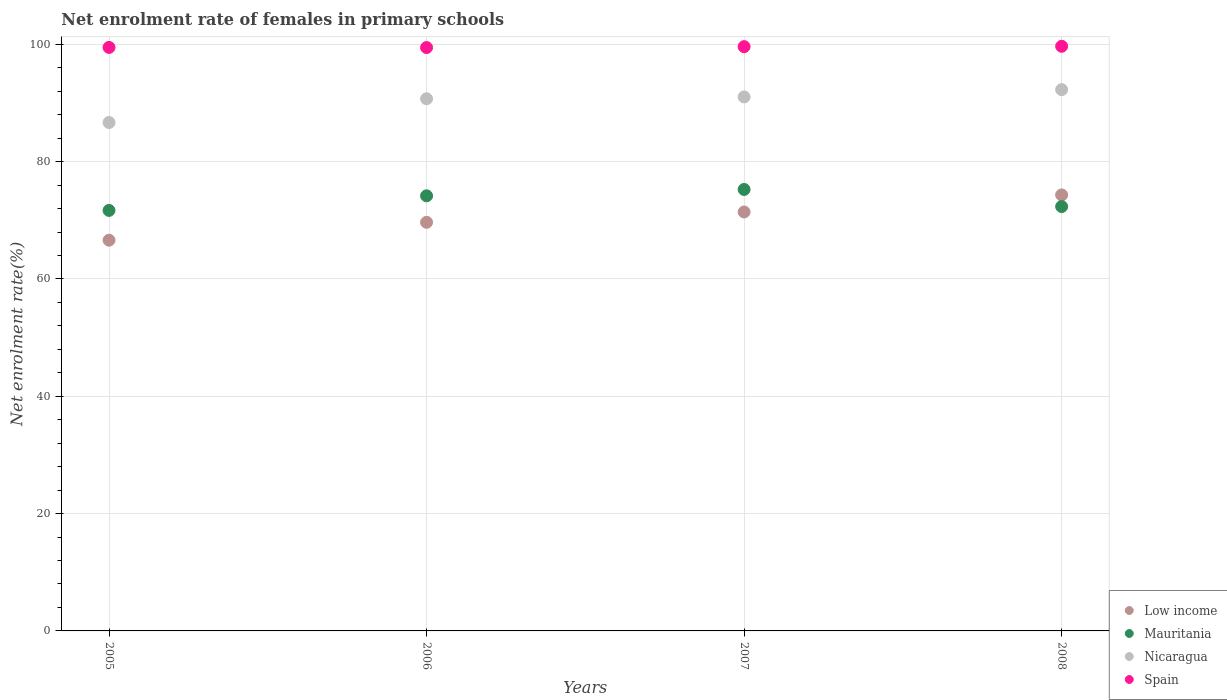Is the number of dotlines equal to the number of legend labels?
Make the answer very short. Yes. What is the net enrolment rate of females in primary schools in Low income in 2006?
Provide a succinct answer. 69.66. Across all years, what is the maximum net enrolment rate of females in primary schools in Low income?
Offer a terse response. 74.33. Across all years, what is the minimum net enrolment rate of females in primary schools in Mauritania?
Your answer should be compact. 71.69. What is the total net enrolment rate of females in primary schools in Spain in the graph?
Offer a terse response. 398.21. What is the difference between the net enrolment rate of females in primary schools in Low income in 2005 and that in 2007?
Your answer should be very brief. -4.82. What is the difference between the net enrolment rate of females in primary schools in Mauritania in 2007 and the net enrolment rate of females in primary schools in Spain in 2008?
Offer a terse response. -24.41. What is the average net enrolment rate of females in primary schools in Spain per year?
Give a very brief answer. 99.55. In the year 2007, what is the difference between the net enrolment rate of females in primary schools in Spain and net enrolment rate of females in primary schools in Nicaragua?
Provide a succinct answer. 8.57. In how many years, is the net enrolment rate of females in primary schools in Nicaragua greater than 24 %?
Ensure brevity in your answer.  4. What is the ratio of the net enrolment rate of females in primary schools in Mauritania in 2005 to that in 2007?
Your response must be concise. 0.95. Is the net enrolment rate of females in primary schools in Spain in 2005 less than that in 2006?
Provide a short and direct response. No. What is the difference between the highest and the second highest net enrolment rate of females in primary schools in Spain?
Ensure brevity in your answer.  0.06. What is the difference between the highest and the lowest net enrolment rate of females in primary schools in Mauritania?
Your answer should be compact. 3.57. In how many years, is the net enrolment rate of females in primary schools in Low income greater than the average net enrolment rate of females in primary schools in Low income taken over all years?
Give a very brief answer. 2. Is it the case that in every year, the sum of the net enrolment rate of females in primary schools in Low income and net enrolment rate of females in primary schools in Spain  is greater than the net enrolment rate of females in primary schools in Nicaragua?
Keep it short and to the point. Yes. Is the net enrolment rate of females in primary schools in Low income strictly greater than the net enrolment rate of females in primary schools in Spain over the years?
Give a very brief answer. No. How many years are there in the graph?
Ensure brevity in your answer.  4. Does the graph contain any zero values?
Give a very brief answer. No. Does the graph contain grids?
Offer a terse response. Yes. What is the title of the graph?
Keep it short and to the point. Net enrolment rate of females in primary schools. Does "Italy" appear as one of the legend labels in the graph?
Your answer should be very brief. No. What is the label or title of the X-axis?
Provide a succinct answer. Years. What is the label or title of the Y-axis?
Your answer should be compact. Net enrolment rate(%). What is the Net enrolment rate(%) in Low income in 2005?
Offer a very short reply. 66.61. What is the Net enrolment rate(%) in Mauritania in 2005?
Offer a very short reply. 71.69. What is the Net enrolment rate(%) in Nicaragua in 2005?
Your answer should be very brief. 86.67. What is the Net enrolment rate(%) of Spain in 2005?
Provide a succinct answer. 99.48. What is the Net enrolment rate(%) in Low income in 2006?
Give a very brief answer. 69.66. What is the Net enrolment rate(%) in Mauritania in 2006?
Make the answer very short. 74.18. What is the Net enrolment rate(%) of Nicaragua in 2006?
Offer a terse response. 90.72. What is the Net enrolment rate(%) of Spain in 2006?
Provide a succinct answer. 99.45. What is the Net enrolment rate(%) of Low income in 2007?
Your answer should be very brief. 71.43. What is the Net enrolment rate(%) of Mauritania in 2007?
Make the answer very short. 75.26. What is the Net enrolment rate(%) of Nicaragua in 2007?
Make the answer very short. 91.03. What is the Net enrolment rate(%) in Spain in 2007?
Make the answer very short. 99.61. What is the Net enrolment rate(%) in Low income in 2008?
Your answer should be very brief. 74.33. What is the Net enrolment rate(%) in Mauritania in 2008?
Offer a terse response. 72.34. What is the Net enrolment rate(%) of Nicaragua in 2008?
Your answer should be very brief. 92.28. What is the Net enrolment rate(%) of Spain in 2008?
Keep it short and to the point. 99.67. Across all years, what is the maximum Net enrolment rate(%) of Low income?
Provide a short and direct response. 74.33. Across all years, what is the maximum Net enrolment rate(%) in Mauritania?
Your answer should be compact. 75.26. Across all years, what is the maximum Net enrolment rate(%) of Nicaragua?
Your answer should be compact. 92.28. Across all years, what is the maximum Net enrolment rate(%) of Spain?
Provide a short and direct response. 99.67. Across all years, what is the minimum Net enrolment rate(%) of Low income?
Make the answer very short. 66.61. Across all years, what is the minimum Net enrolment rate(%) in Mauritania?
Your answer should be very brief. 71.69. Across all years, what is the minimum Net enrolment rate(%) of Nicaragua?
Your response must be concise. 86.67. Across all years, what is the minimum Net enrolment rate(%) of Spain?
Your answer should be very brief. 99.45. What is the total Net enrolment rate(%) of Low income in the graph?
Keep it short and to the point. 282.02. What is the total Net enrolment rate(%) in Mauritania in the graph?
Ensure brevity in your answer.  293.47. What is the total Net enrolment rate(%) in Nicaragua in the graph?
Offer a very short reply. 360.71. What is the total Net enrolment rate(%) of Spain in the graph?
Offer a very short reply. 398.21. What is the difference between the Net enrolment rate(%) of Low income in 2005 and that in 2006?
Keep it short and to the point. -3.05. What is the difference between the Net enrolment rate(%) of Mauritania in 2005 and that in 2006?
Provide a succinct answer. -2.49. What is the difference between the Net enrolment rate(%) of Nicaragua in 2005 and that in 2006?
Make the answer very short. -4.05. What is the difference between the Net enrolment rate(%) of Spain in 2005 and that in 2006?
Keep it short and to the point. 0.02. What is the difference between the Net enrolment rate(%) of Low income in 2005 and that in 2007?
Your response must be concise. -4.82. What is the difference between the Net enrolment rate(%) of Mauritania in 2005 and that in 2007?
Make the answer very short. -3.57. What is the difference between the Net enrolment rate(%) of Nicaragua in 2005 and that in 2007?
Your answer should be compact. -4.36. What is the difference between the Net enrolment rate(%) of Spain in 2005 and that in 2007?
Ensure brevity in your answer.  -0.13. What is the difference between the Net enrolment rate(%) in Low income in 2005 and that in 2008?
Ensure brevity in your answer.  -7.72. What is the difference between the Net enrolment rate(%) of Mauritania in 2005 and that in 2008?
Keep it short and to the point. -0.66. What is the difference between the Net enrolment rate(%) in Nicaragua in 2005 and that in 2008?
Keep it short and to the point. -5.6. What is the difference between the Net enrolment rate(%) of Spain in 2005 and that in 2008?
Offer a terse response. -0.2. What is the difference between the Net enrolment rate(%) in Low income in 2006 and that in 2007?
Provide a short and direct response. -1.77. What is the difference between the Net enrolment rate(%) of Mauritania in 2006 and that in 2007?
Offer a terse response. -1.08. What is the difference between the Net enrolment rate(%) in Nicaragua in 2006 and that in 2007?
Your answer should be compact. -0.31. What is the difference between the Net enrolment rate(%) in Spain in 2006 and that in 2007?
Keep it short and to the point. -0.15. What is the difference between the Net enrolment rate(%) in Low income in 2006 and that in 2008?
Offer a very short reply. -4.67. What is the difference between the Net enrolment rate(%) of Mauritania in 2006 and that in 2008?
Provide a succinct answer. 1.83. What is the difference between the Net enrolment rate(%) of Nicaragua in 2006 and that in 2008?
Keep it short and to the point. -1.55. What is the difference between the Net enrolment rate(%) of Spain in 2006 and that in 2008?
Make the answer very short. -0.22. What is the difference between the Net enrolment rate(%) of Low income in 2007 and that in 2008?
Offer a very short reply. -2.9. What is the difference between the Net enrolment rate(%) of Mauritania in 2007 and that in 2008?
Provide a short and direct response. 2.92. What is the difference between the Net enrolment rate(%) in Nicaragua in 2007 and that in 2008?
Provide a short and direct response. -1.24. What is the difference between the Net enrolment rate(%) of Spain in 2007 and that in 2008?
Ensure brevity in your answer.  -0.06. What is the difference between the Net enrolment rate(%) of Low income in 2005 and the Net enrolment rate(%) of Mauritania in 2006?
Provide a succinct answer. -7.57. What is the difference between the Net enrolment rate(%) of Low income in 2005 and the Net enrolment rate(%) of Nicaragua in 2006?
Ensure brevity in your answer.  -24.11. What is the difference between the Net enrolment rate(%) in Low income in 2005 and the Net enrolment rate(%) in Spain in 2006?
Give a very brief answer. -32.84. What is the difference between the Net enrolment rate(%) in Mauritania in 2005 and the Net enrolment rate(%) in Nicaragua in 2006?
Your answer should be compact. -19.03. What is the difference between the Net enrolment rate(%) of Mauritania in 2005 and the Net enrolment rate(%) of Spain in 2006?
Offer a very short reply. -27.76. What is the difference between the Net enrolment rate(%) in Nicaragua in 2005 and the Net enrolment rate(%) in Spain in 2006?
Offer a terse response. -12.78. What is the difference between the Net enrolment rate(%) of Low income in 2005 and the Net enrolment rate(%) of Mauritania in 2007?
Provide a succinct answer. -8.65. What is the difference between the Net enrolment rate(%) of Low income in 2005 and the Net enrolment rate(%) of Nicaragua in 2007?
Keep it short and to the point. -24.42. What is the difference between the Net enrolment rate(%) in Low income in 2005 and the Net enrolment rate(%) in Spain in 2007?
Keep it short and to the point. -33. What is the difference between the Net enrolment rate(%) of Mauritania in 2005 and the Net enrolment rate(%) of Nicaragua in 2007?
Offer a very short reply. -19.34. What is the difference between the Net enrolment rate(%) in Mauritania in 2005 and the Net enrolment rate(%) in Spain in 2007?
Make the answer very short. -27.92. What is the difference between the Net enrolment rate(%) in Nicaragua in 2005 and the Net enrolment rate(%) in Spain in 2007?
Make the answer very short. -12.93. What is the difference between the Net enrolment rate(%) of Low income in 2005 and the Net enrolment rate(%) of Mauritania in 2008?
Your response must be concise. -5.73. What is the difference between the Net enrolment rate(%) in Low income in 2005 and the Net enrolment rate(%) in Nicaragua in 2008?
Offer a very short reply. -25.67. What is the difference between the Net enrolment rate(%) of Low income in 2005 and the Net enrolment rate(%) of Spain in 2008?
Your answer should be very brief. -33.06. What is the difference between the Net enrolment rate(%) of Mauritania in 2005 and the Net enrolment rate(%) of Nicaragua in 2008?
Offer a terse response. -20.59. What is the difference between the Net enrolment rate(%) in Mauritania in 2005 and the Net enrolment rate(%) in Spain in 2008?
Offer a very short reply. -27.98. What is the difference between the Net enrolment rate(%) in Nicaragua in 2005 and the Net enrolment rate(%) in Spain in 2008?
Keep it short and to the point. -13. What is the difference between the Net enrolment rate(%) of Low income in 2006 and the Net enrolment rate(%) of Mauritania in 2007?
Offer a very short reply. -5.6. What is the difference between the Net enrolment rate(%) in Low income in 2006 and the Net enrolment rate(%) in Nicaragua in 2007?
Offer a terse response. -21.37. What is the difference between the Net enrolment rate(%) of Low income in 2006 and the Net enrolment rate(%) of Spain in 2007?
Offer a very short reply. -29.95. What is the difference between the Net enrolment rate(%) in Mauritania in 2006 and the Net enrolment rate(%) in Nicaragua in 2007?
Keep it short and to the point. -16.86. What is the difference between the Net enrolment rate(%) in Mauritania in 2006 and the Net enrolment rate(%) in Spain in 2007?
Your response must be concise. -25.43. What is the difference between the Net enrolment rate(%) in Nicaragua in 2006 and the Net enrolment rate(%) in Spain in 2007?
Your answer should be compact. -8.89. What is the difference between the Net enrolment rate(%) in Low income in 2006 and the Net enrolment rate(%) in Mauritania in 2008?
Offer a terse response. -2.68. What is the difference between the Net enrolment rate(%) of Low income in 2006 and the Net enrolment rate(%) of Nicaragua in 2008?
Your answer should be very brief. -22.61. What is the difference between the Net enrolment rate(%) in Low income in 2006 and the Net enrolment rate(%) in Spain in 2008?
Give a very brief answer. -30.01. What is the difference between the Net enrolment rate(%) of Mauritania in 2006 and the Net enrolment rate(%) of Nicaragua in 2008?
Your answer should be compact. -18.1. What is the difference between the Net enrolment rate(%) in Mauritania in 2006 and the Net enrolment rate(%) in Spain in 2008?
Give a very brief answer. -25.5. What is the difference between the Net enrolment rate(%) of Nicaragua in 2006 and the Net enrolment rate(%) of Spain in 2008?
Your answer should be very brief. -8.95. What is the difference between the Net enrolment rate(%) in Low income in 2007 and the Net enrolment rate(%) in Mauritania in 2008?
Make the answer very short. -0.92. What is the difference between the Net enrolment rate(%) of Low income in 2007 and the Net enrolment rate(%) of Nicaragua in 2008?
Provide a succinct answer. -20.85. What is the difference between the Net enrolment rate(%) in Low income in 2007 and the Net enrolment rate(%) in Spain in 2008?
Provide a succinct answer. -28.25. What is the difference between the Net enrolment rate(%) in Mauritania in 2007 and the Net enrolment rate(%) in Nicaragua in 2008?
Give a very brief answer. -17.01. What is the difference between the Net enrolment rate(%) of Mauritania in 2007 and the Net enrolment rate(%) of Spain in 2008?
Ensure brevity in your answer.  -24.41. What is the difference between the Net enrolment rate(%) of Nicaragua in 2007 and the Net enrolment rate(%) of Spain in 2008?
Provide a succinct answer. -8.64. What is the average Net enrolment rate(%) of Low income per year?
Ensure brevity in your answer.  70.51. What is the average Net enrolment rate(%) in Mauritania per year?
Make the answer very short. 73.37. What is the average Net enrolment rate(%) in Nicaragua per year?
Make the answer very short. 90.18. What is the average Net enrolment rate(%) in Spain per year?
Provide a succinct answer. 99.55. In the year 2005, what is the difference between the Net enrolment rate(%) of Low income and Net enrolment rate(%) of Mauritania?
Give a very brief answer. -5.08. In the year 2005, what is the difference between the Net enrolment rate(%) of Low income and Net enrolment rate(%) of Nicaragua?
Keep it short and to the point. -20.06. In the year 2005, what is the difference between the Net enrolment rate(%) of Low income and Net enrolment rate(%) of Spain?
Provide a short and direct response. -32.87. In the year 2005, what is the difference between the Net enrolment rate(%) in Mauritania and Net enrolment rate(%) in Nicaragua?
Provide a short and direct response. -14.99. In the year 2005, what is the difference between the Net enrolment rate(%) in Mauritania and Net enrolment rate(%) in Spain?
Provide a short and direct response. -27.79. In the year 2005, what is the difference between the Net enrolment rate(%) in Nicaragua and Net enrolment rate(%) in Spain?
Your answer should be very brief. -12.8. In the year 2006, what is the difference between the Net enrolment rate(%) in Low income and Net enrolment rate(%) in Mauritania?
Offer a very short reply. -4.52. In the year 2006, what is the difference between the Net enrolment rate(%) of Low income and Net enrolment rate(%) of Nicaragua?
Ensure brevity in your answer.  -21.06. In the year 2006, what is the difference between the Net enrolment rate(%) in Low income and Net enrolment rate(%) in Spain?
Make the answer very short. -29.79. In the year 2006, what is the difference between the Net enrolment rate(%) in Mauritania and Net enrolment rate(%) in Nicaragua?
Provide a succinct answer. -16.54. In the year 2006, what is the difference between the Net enrolment rate(%) of Mauritania and Net enrolment rate(%) of Spain?
Your answer should be very brief. -25.28. In the year 2006, what is the difference between the Net enrolment rate(%) of Nicaragua and Net enrolment rate(%) of Spain?
Offer a terse response. -8.73. In the year 2007, what is the difference between the Net enrolment rate(%) of Low income and Net enrolment rate(%) of Mauritania?
Make the answer very short. -3.83. In the year 2007, what is the difference between the Net enrolment rate(%) of Low income and Net enrolment rate(%) of Nicaragua?
Your response must be concise. -19.61. In the year 2007, what is the difference between the Net enrolment rate(%) of Low income and Net enrolment rate(%) of Spain?
Offer a very short reply. -28.18. In the year 2007, what is the difference between the Net enrolment rate(%) in Mauritania and Net enrolment rate(%) in Nicaragua?
Offer a very short reply. -15.77. In the year 2007, what is the difference between the Net enrolment rate(%) of Mauritania and Net enrolment rate(%) of Spain?
Your answer should be compact. -24.35. In the year 2007, what is the difference between the Net enrolment rate(%) in Nicaragua and Net enrolment rate(%) in Spain?
Give a very brief answer. -8.57. In the year 2008, what is the difference between the Net enrolment rate(%) of Low income and Net enrolment rate(%) of Mauritania?
Your answer should be compact. 1.98. In the year 2008, what is the difference between the Net enrolment rate(%) in Low income and Net enrolment rate(%) in Nicaragua?
Give a very brief answer. -17.95. In the year 2008, what is the difference between the Net enrolment rate(%) of Low income and Net enrolment rate(%) of Spain?
Make the answer very short. -25.34. In the year 2008, what is the difference between the Net enrolment rate(%) of Mauritania and Net enrolment rate(%) of Nicaragua?
Your answer should be very brief. -19.93. In the year 2008, what is the difference between the Net enrolment rate(%) in Mauritania and Net enrolment rate(%) in Spain?
Your answer should be very brief. -27.33. In the year 2008, what is the difference between the Net enrolment rate(%) of Nicaragua and Net enrolment rate(%) of Spain?
Provide a succinct answer. -7.4. What is the ratio of the Net enrolment rate(%) of Low income in 2005 to that in 2006?
Your response must be concise. 0.96. What is the ratio of the Net enrolment rate(%) in Mauritania in 2005 to that in 2006?
Offer a very short reply. 0.97. What is the ratio of the Net enrolment rate(%) in Nicaragua in 2005 to that in 2006?
Your answer should be very brief. 0.96. What is the ratio of the Net enrolment rate(%) in Low income in 2005 to that in 2007?
Your answer should be very brief. 0.93. What is the ratio of the Net enrolment rate(%) in Mauritania in 2005 to that in 2007?
Offer a terse response. 0.95. What is the ratio of the Net enrolment rate(%) of Nicaragua in 2005 to that in 2007?
Provide a succinct answer. 0.95. What is the ratio of the Net enrolment rate(%) in Low income in 2005 to that in 2008?
Offer a very short reply. 0.9. What is the ratio of the Net enrolment rate(%) in Mauritania in 2005 to that in 2008?
Offer a very short reply. 0.99. What is the ratio of the Net enrolment rate(%) of Nicaragua in 2005 to that in 2008?
Make the answer very short. 0.94. What is the ratio of the Net enrolment rate(%) in Spain in 2005 to that in 2008?
Offer a very short reply. 1. What is the ratio of the Net enrolment rate(%) in Low income in 2006 to that in 2007?
Provide a short and direct response. 0.98. What is the ratio of the Net enrolment rate(%) of Mauritania in 2006 to that in 2007?
Offer a very short reply. 0.99. What is the ratio of the Net enrolment rate(%) of Nicaragua in 2006 to that in 2007?
Ensure brevity in your answer.  1. What is the ratio of the Net enrolment rate(%) in Low income in 2006 to that in 2008?
Make the answer very short. 0.94. What is the ratio of the Net enrolment rate(%) in Mauritania in 2006 to that in 2008?
Ensure brevity in your answer.  1.03. What is the ratio of the Net enrolment rate(%) of Nicaragua in 2006 to that in 2008?
Make the answer very short. 0.98. What is the ratio of the Net enrolment rate(%) of Mauritania in 2007 to that in 2008?
Your answer should be compact. 1.04. What is the ratio of the Net enrolment rate(%) of Nicaragua in 2007 to that in 2008?
Give a very brief answer. 0.99. What is the ratio of the Net enrolment rate(%) of Spain in 2007 to that in 2008?
Your response must be concise. 1. What is the difference between the highest and the second highest Net enrolment rate(%) of Low income?
Make the answer very short. 2.9. What is the difference between the highest and the second highest Net enrolment rate(%) of Mauritania?
Keep it short and to the point. 1.08. What is the difference between the highest and the second highest Net enrolment rate(%) of Nicaragua?
Offer a terse response. 1.24. What is the difference between the highest and the second highest Net enrolment rate(%) of Spain?
Provide a short and direct response. 0.06. What is the difference between the highest and the lowest Net enrolment rate(%) of Low income?
Provide a succinct answer. 7.72. What is the difference between the highest and the lowest Net enrolment rate(%) in Mauritania?
Offer a very short reply. 3.57. What is the difference between the highest and the lowest Net enrolment rate(%) in Nicaragua?
Your response must be concise. 5.6. What is the difference between the highest and the lowest Net enrolment rate(%) of Spain?
Provide a succinct answer. 0.22. 